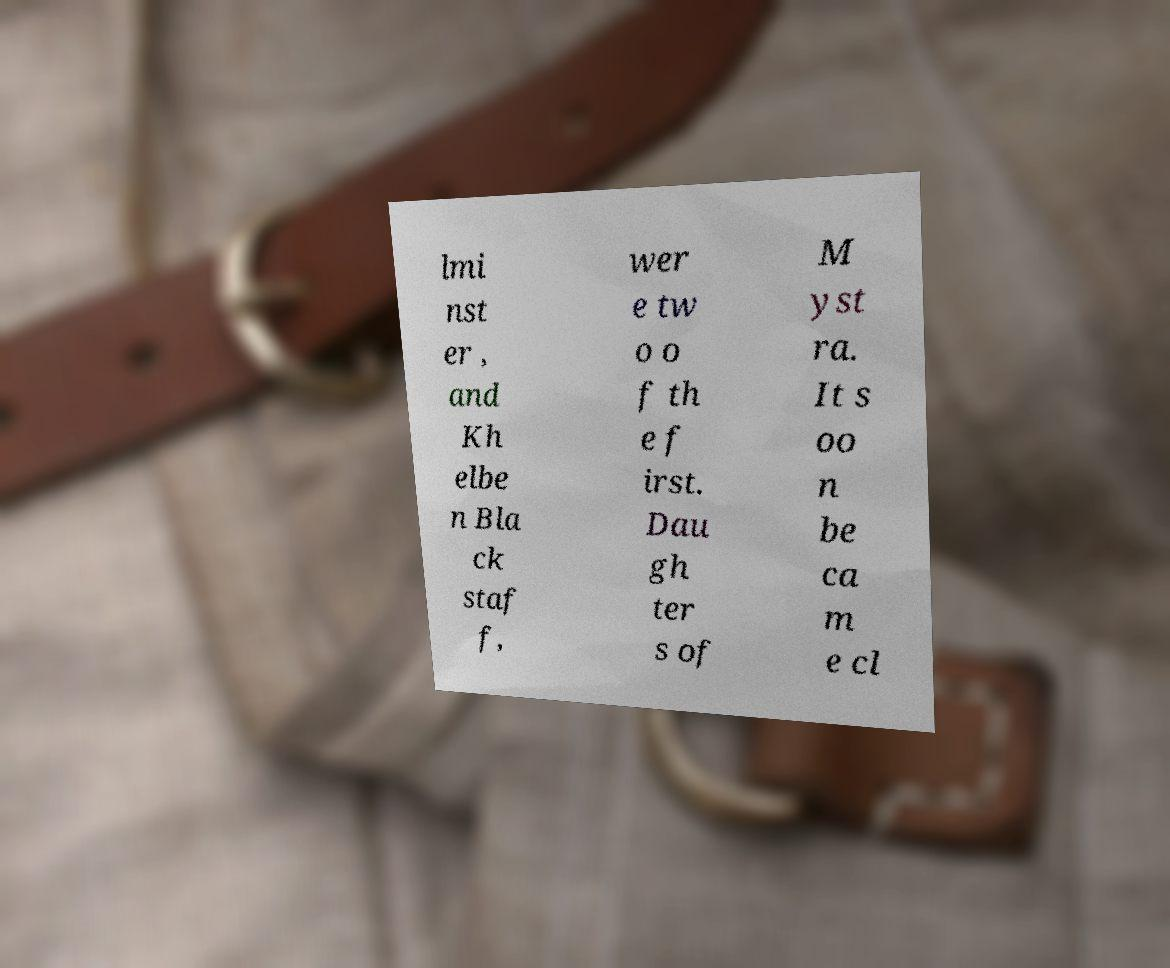For documentation purposes, I need the text within this image transcribed. Could you provide that? lmi nst er , and Kh elbe n Bla ck staf f, wer e tw o o f th e f irst. Dau gh ter s of M yst ra. It s oo n be ca m e cl 